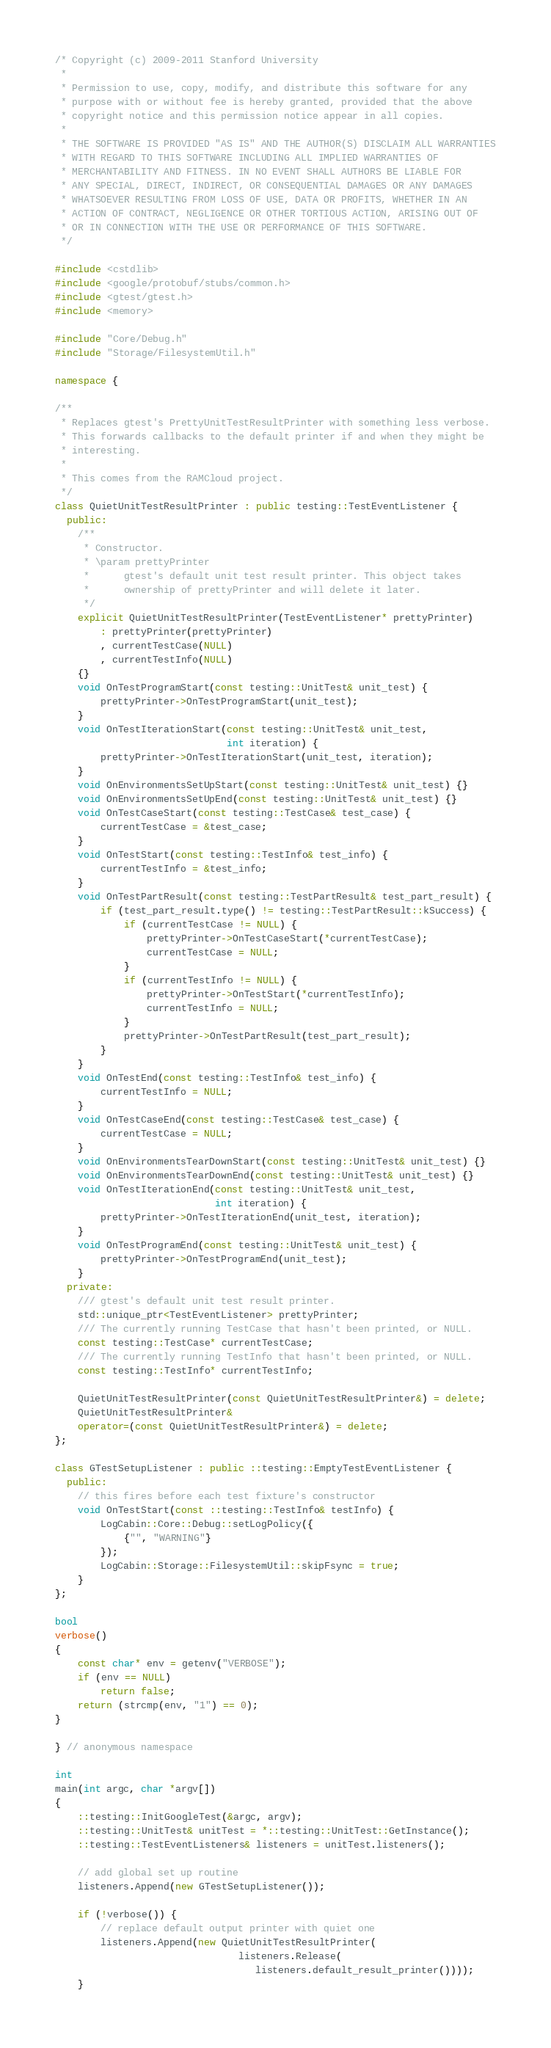Convert code to text. <code><loc_0><loc_0><loc_500><loc_500><_C++_>/* Copyright (c) 2009-2011 Stanford University
 *
 * Permission to use, copy, modify, and distribute this software for any
 * purpose with or without fee is hereby granted, provided that the above
 * copyright notice and this permission notice appear in all copies.
 *
 * THE SOFTWARE IS PROVIDED "AS IS" AND THE AUTHOR(S) DISCLAIM ALL WARRANTIES
 * WITH REGARD TO THIS SOFTWARE INCLUDING ALL IMPLIED WARRANTIES OF
 * MERCHANTABILITY AND FITNESS. IN NO EVENT SHALL AUTHORS BE LIABLE FOR
 * ANY SPECIAL, DIRECT, INDIRECT, OR CONSEQUENTIAL DAMAGES OR ANY DAMAGES
 * WHATSOEVER RESULTING FROM LOSS OF USE, DATA OR PROFITS, WHETHER IN AN
 * ACTION OF CONTRACT, NEGLIGENCE OR OTHER TORTIOUS ACTION, ARISING OUT OF
 * OR IN CONNECTION WITH THE USE OR PERFORMANCE OF THIS SOFTWARE.
 */

#include <cstdlib>
#include <google/protobuf/stubs/common.h>
#include <gtest/gtest.h>
#include <memory>

#include "Core/Debug.h"
#include "Storage/FilesystemUtil.h"

namespace {

/**
 * Replaces gtest's PrettyUnitTestResultPrinter with something less verbose.
 * This forwards callbacks to the default printer if and when they might be
 * interesting.
 *
 * This comes from the RAMCloud project.
 */
class QuietUnitTestResultPrinter : public testing::TestEventListener {
  public:
    /**
     * Constructor.
     * \param prettyPrinter
     *      gtest's default unit test result printer. This object takes
     *      ownership of prettyPrinter and will delete it later.
     */
    explicit QuietUnitTestResultPrinter(TestEventListener* prettyPrinter)
        : prettyPrinter(prettyPrinter)
        , currentTestCase(NULL)
        , currentTestInfo(NULL)
    {}
    void OnTestProgramStart(const testing::UnitTest& unit_test) {
        prettyPrinter->OnTestProgramStart(unit_test);
    }
    void OnTestIterationStart(const testing::UnitTest& unit_test,
                              int iteration) {
        prettyPrinter->OnTestIterationStart(unit_test, iteration);
    }
    void OnEnvironmentsSetUpStart(const testing::UnitTest& unit_test) {}
    void OnEnvironmentsSetUpEnd(const testing::UnitTest& unit_test) {}
    void OnTestCaseStart(const testing::TestCase& test_case) {
        currentTestCase = &test_case;
    }
    void OnTestStart(const testing::TestInfo& test_info) {
        currentTestInfo = &test_info;
    }
    void OnTestPartResult(const testing::TestPartResult& test_part_result) {
        if (test_part_result.type() != testing::TestPartResult::kSuccess) {
            if (currentTestCase != NULL) {
                prettyPrinter->OnTestCaseStart(*currentTestCase);
                currentTestCase = NULL;
            }
            if (currentTestInfo != NULL) {
                prettyPrinter->OnTestStart(*currentTestInfo);
                currentTestInfo = NULL;
            }
            prettyPrinter->OnTestPartResult(test_part_result);
        }
    }
    void OnTestEnd(const testing::TestInfo& test_info) {
        currentTestInfo = NULL;
    }
    void OnTestCaseEnd(const testing::TestCase& test_case) {
        currentTestCase = NULL;
    }
    void OnEnvironmentsTearDownStart(const testing::UnitTest& unit_test) {}
    void OnEnvironmentsTearDownEnd(const testing::UnitTest& unit_test) {}
    void OnTestIterationEnd(const testing::UnitTest& unit_test,
                            int iteration) {
        prettyPrinter->OnTestIterationEnd(unit_test, iteration);
    }
    void OnTestProgramEnd(const testing::UnitTest& unit_test) {
        prettyPrinter->OnTestProgramEnd(unit_test);
    }
  private:
    /// gtest's default unit test result printer.
    std::unique_ptr<TestEventListener> prettyPrinter;
    /// The currently running TestCase that hasn't been printed, or NULL.
    const testing::TestCase* currentTestCase;
    /// The currently running TestInfo that hasn't been printed, or NULL.
    const testing::TestInfo* currentTestInfo;

    QuietUnitTestResultPrinter(const QuietUnitTestResultPrinter&) = delete;
    QuietUnitTestResultPrinter&
    operator=(const QuietUnitTestResultPrinter&) = delete;
};

class GTestSetupListener : public ::testing::EmptyTestEventListener {
  public:
    // this fires before each test fixture's constructor
    void OnTestStart(const ::testing::TestInfo& testInfo) {
        LogCabin::Core::Debug::setLogPolicy({
            {"", "WARNING"}
        });
        LogCabin::Storage::FilesystemUtil::skipFsync = true;
    }
};

bool
verbose()
{
    const char* env = getenv("VERBOSE");
    if (env == NULL)
        return false;
    return (strcmp(env, "1") == 0);
}

} // anonymous namespace

int
main(int argc, char *argv[])
{
    ::testing::InitGoogleTest(&argc, argv);
    ::testing::UnitTest& unitTest = *::testing::UnitTest::GetInstance();
    ::testing::TestEventListeners& listeners = unitTest.listeners();

    // add global set up routine
    listeners.Append(new GTestSetupListener());

    if (!verbose()) {
        // replace default output printer with quiet one
        listeners.Append(new QuietUnitTestResultPrinter(
                                listeners.Release(
                                   listeners.default_result_printer())));
    }
</code> 